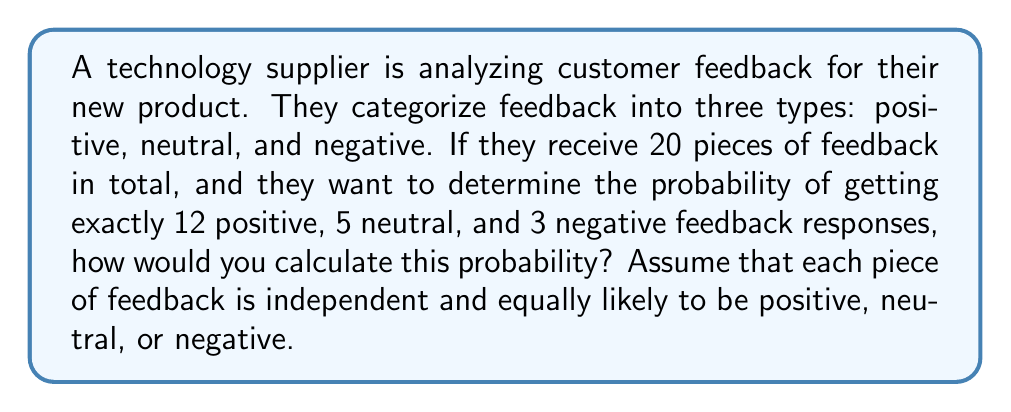Solve this math problem. To solve this problem, we'll use the concept of multinomial probability distribution, which is an extension of the binomial distribution for more than two outcomes.

1) First, we need to calculate the total number of ways to arrange 20 pieces of feedback into 12 positive, 5 neutral, and 3 negative responses. This is given by the multinomial coefficient:

   $$\binom{20}{12,5,3} = \frac{20!}{12!5!3!}$$

2) Next, we need to consider the probability of each individual outcome. Since each piece of feedback is equally likely to be positive, neutral, or negative, the probability of each is $\frac{1}{3}$.

3) The probability of this specific arrangement is then:

   $$P(12 \text{ positive}, 5 \text{ neutral}, 3 \text{ negative}) = \binom{20}{12,5,3} \cdot \left(\frac{1}{3}\right)^{12} \cdot \left(\frac{1}{3}\right)^{5} \cdot \left(\frac{1}{3}\right)^{3}$$

4) Let's calculate each part:
   
   $$\binom{20}{12,5,3} = \frac{20!}{12!5!3!} = 7,054,320$$
   
   $$\left(\frac{1}{3}\right)^{20} = \frac{1}{3^{20}} \approx 2.8679 \times 10^{-10}$$

5) Putting it all together:

   $$7,054,320 \cdot 2.8679 \times 10^{-10} \approx 0.002023$$

Therefore, the probability of receiving exactly 12 positive, 5 neutral, and 3 negative feedback responses out of 20 total responses is approximately 0.002023 or about 0.2023%.
Answer: The probability is approximately 0.002023 or 0.2023%. 